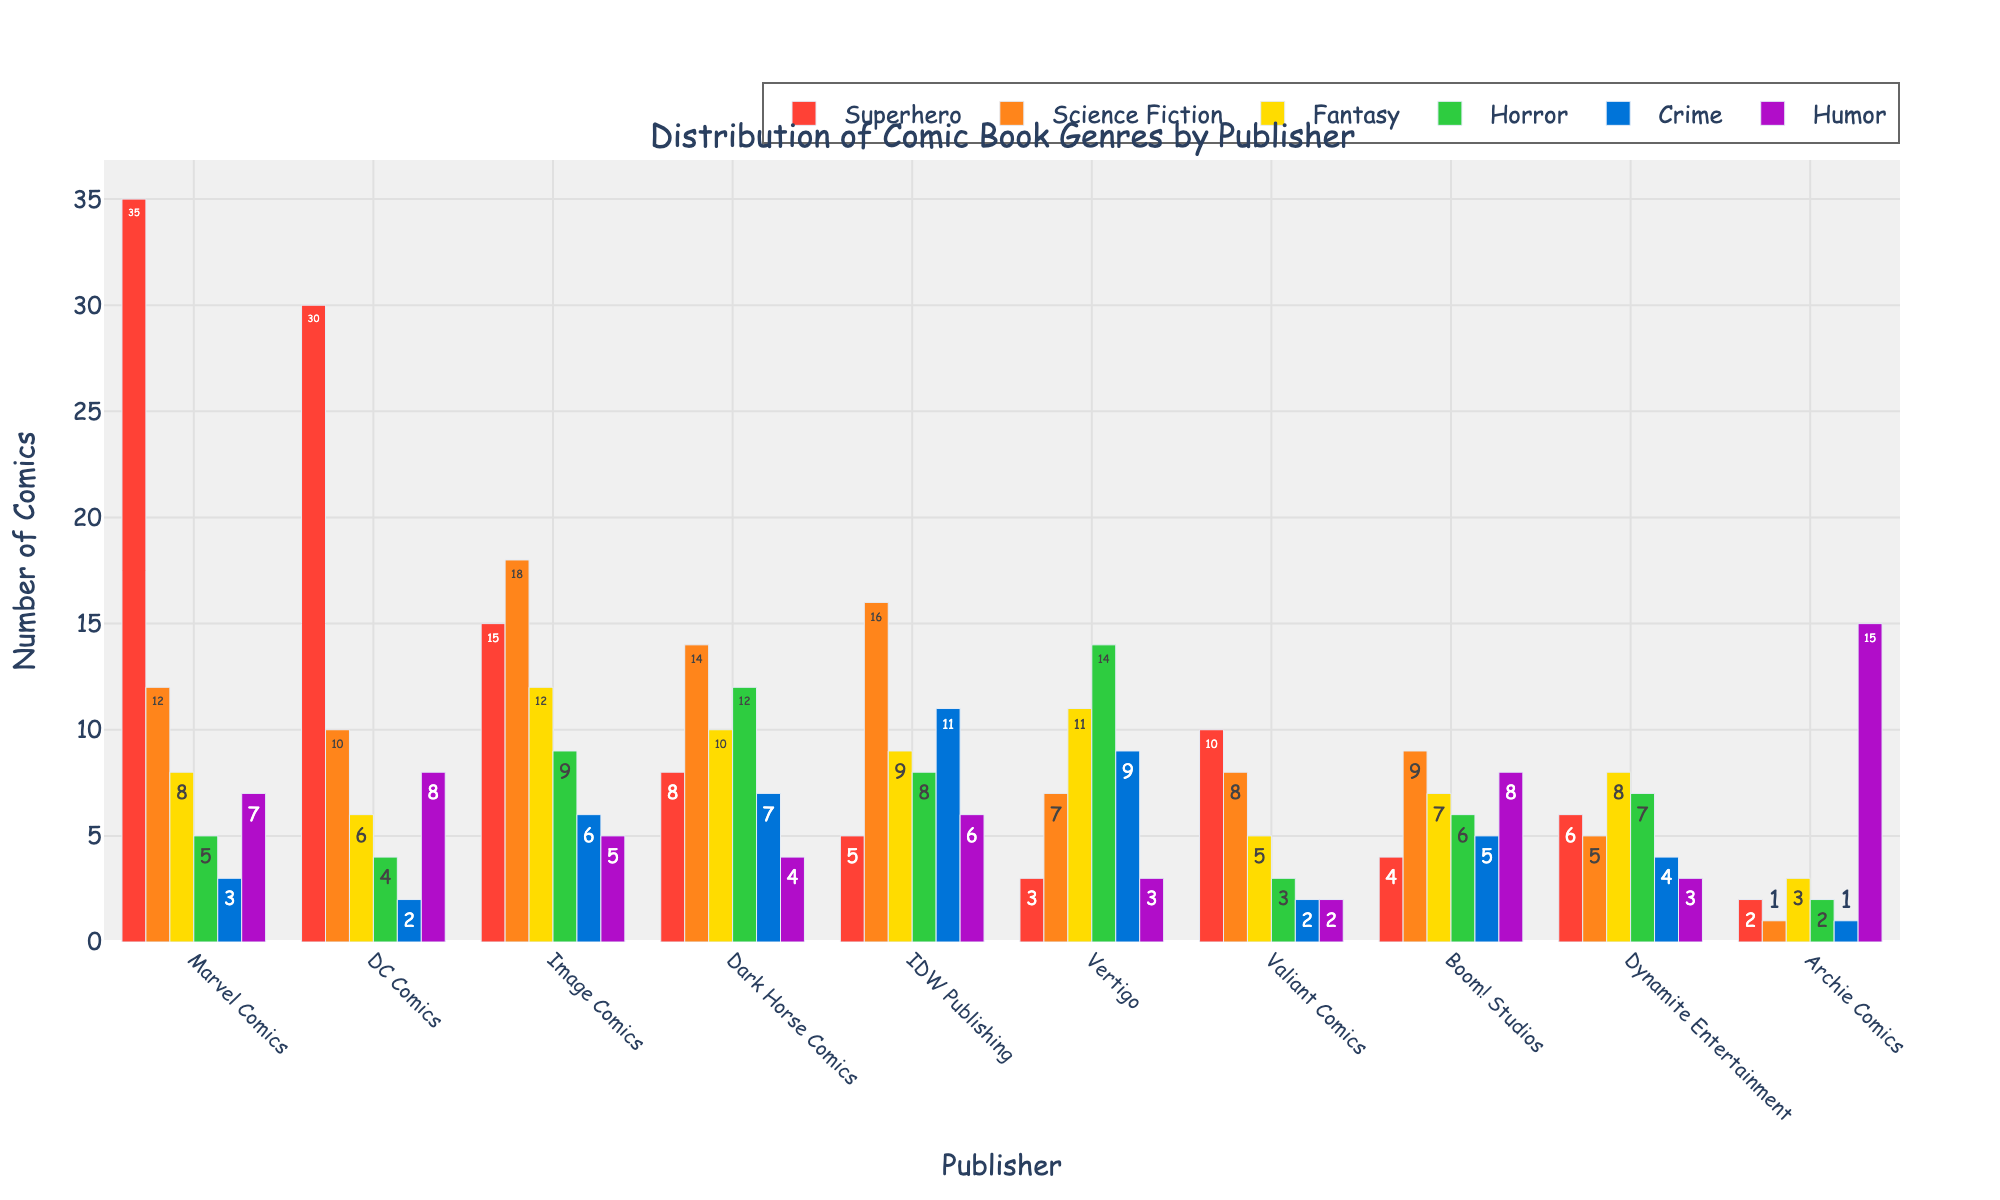Which publisher has the highest number of superhero comics? The height of the bar for superhero comics shows the quantity for each publisher. Marvel Comics has the tallest bar, indicating it has the highest number.
Answer: Marvel Comics What is the total number of horror comics between Dark Horse Comics and Vertigo? Add the number of horror comics for Dark Horse Comics (12) and Vertigo (14). The sum is 12 + 14 = 26.
Answer: 26 How many more superhero comics does Marvel Comics have compared to DC Comics? Subtract the number of superhero comics for DC Comics (30) from Marvel Comics (35). The difference is 35 - 30 = 5.
Answer: 5 Which genre has the largest number of comics across all publishers? By comparing the heights of bars across all genres and publishers, Science Fiction from Image Comics appears the most significant, with 18 comics.
Answer: Science Fiction What is the average number of crime comics per publisher? Sum the number of crime comics for all publishers: 3 + 2 + 6 + 7 + 11 + 9 + 2 + 5 + 4 + 1 = 50. Divide by the number of publishers (10). The average is 50/10 = 5.
Answer: 5 Which genre does Archie Comics have the most of? The height of the bars for Archie Comics indicates the highest number for humor comics, with a quantity of 15.
Answer: Humor Is the number of fantasy comics for Image Comics greater than the number of science fiction comics for Vertigo? Compare the bars for fantasy comics for Image Comics (12) and science fiction comics for Vertigo (7), noticing 12 > 7.
Answer: Yes What is the combined number of humor comics from Marvel Comics, DC Comics, and IDW Publishing? Add the number of humor comics for Marvel Comics (7), DC Comics (8), and IDW Publishing (6). The total is 7 + 8 + 6 = 21.
Answer: 21 What is the median number of superhero comics across all publishers? Arrange the superhero comics counts in ascending order: 2, 3, 4, 5, 6, 8, 10, 15, 30, 35. The median is the average of the 5th and 6th numbers (6 and 8), (6 + 8)/2 = 7.
Answer: 7 